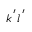Convert formula to latex. <formula><loc_0><loc_0><loc_500><loc_500>k ^ { \, ^ { \prime } } l ^ { \, ^ { \prime } }</formula> 